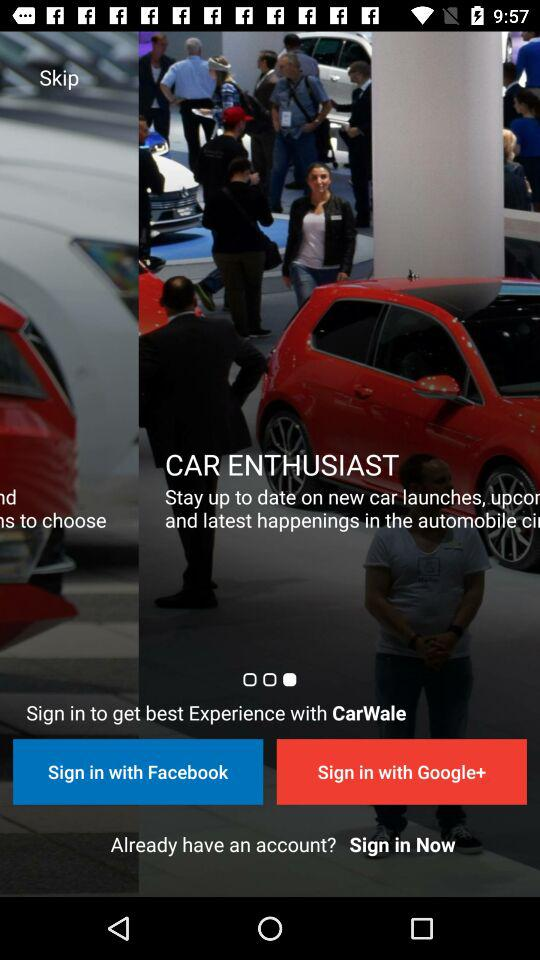What are the options to sign in? The options are "Facebook" and "Google+". 